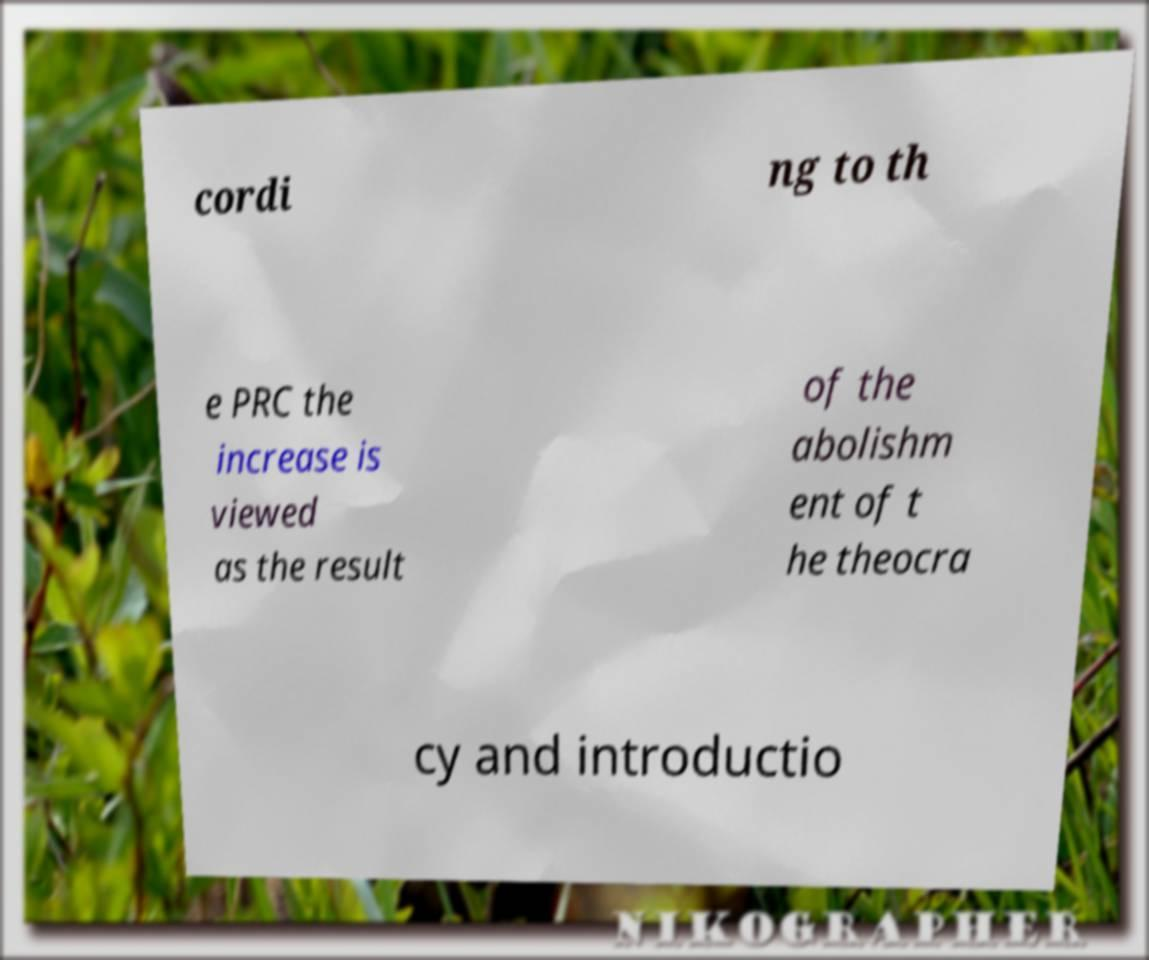Could you extract and type out the text from this image? cordi ng to th e PRC the increase is viewed as the result of the abolishm ent of t he theocra cy and introductio 